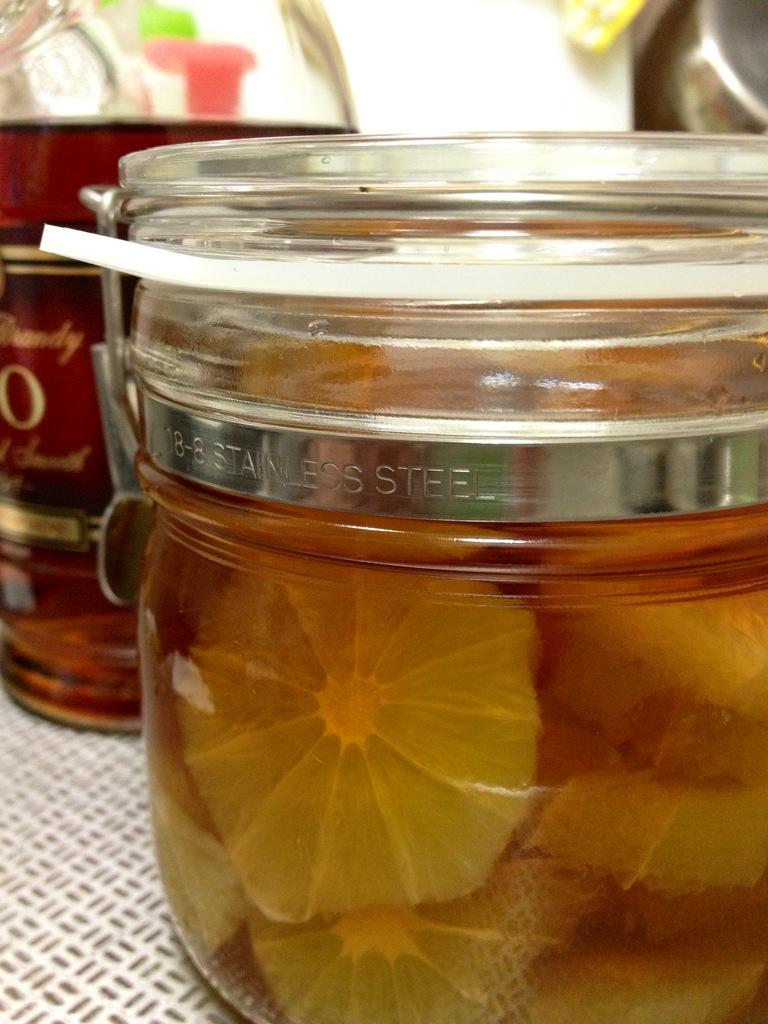What is the main object in the image? There is a glass jar in the image. What is inside the glass jar? The glass jar has something inside it. Can you describe any other objects visible in the image? There are other objects visible in the background of the image. What color is the crayon that the kitty is holding in the image? There is no crayon or kitty present in the image. 